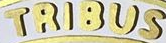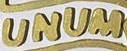Read the text content from these images in order, separated by a semicolon. TRIBUS; UNUM 